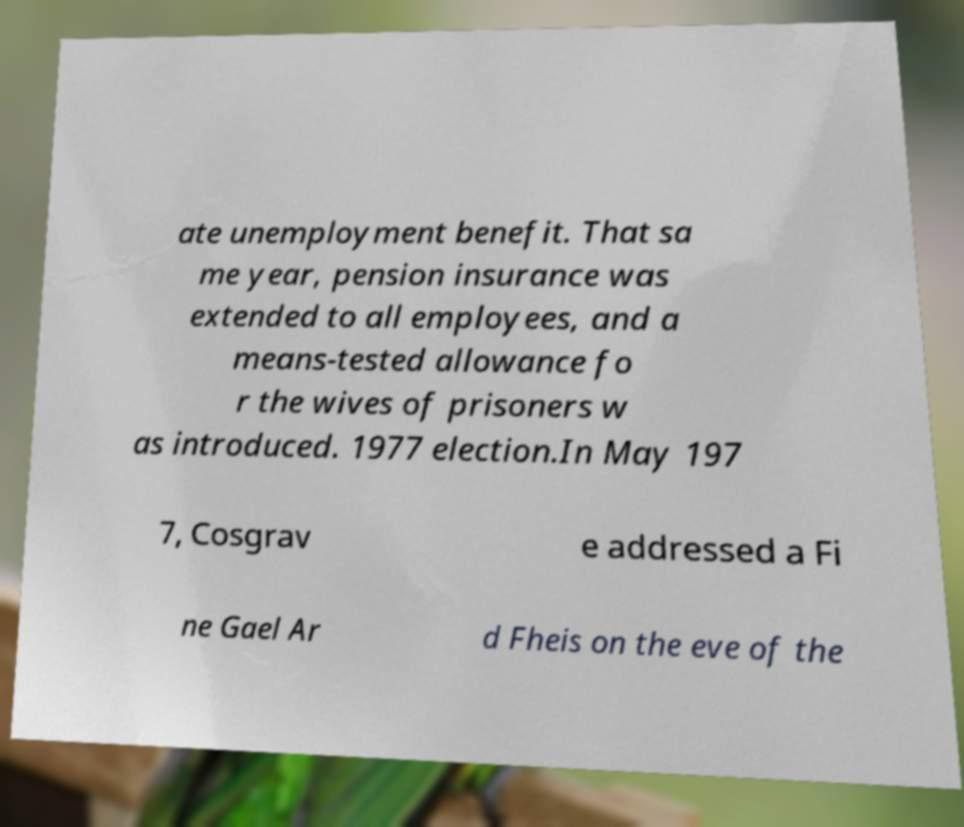Can you read and provide the text displayed in the image?This photo seems to have some interesting text. Can you extract and type it out for me? ate unemployment benefit. That sa me year, pension insurance was extended to all employees, and a means-tested allowance fo r the wives of prisoners w as introduced. 1977 election.In May 197 7, Cosgrav e addressed a Fi ne Gael Ar d Fheis on the eve of the 